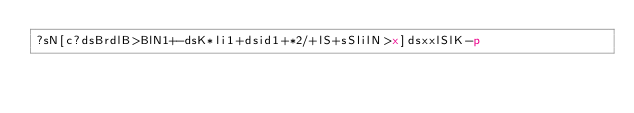Convert code to text. <code><loc_0><loc_0><loc_500><loc_500><_dc_>?sN[c?dsBrdlB>BlN1+-dsK*li1+dsid1+*2/+lS+sSlilN>x]dsxxlSlK-p</code> 